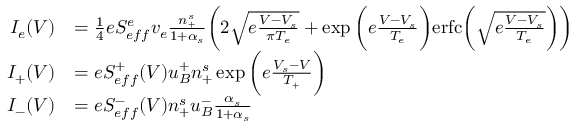<formula> <loc_0><loc_0><loc_500><loc_500>\begin{array} { r l } { I _ { e } ( V ) } & { = \frac { 1 } { 4 } e S _ { e f f } ^ { e } v _ { e } \frac { n _ { + } ^ { s } } { 1 + \alpha _ { s } } \left ( 2 \sqrt { e \frac { V - V _ { s } } { \pi T _ { e } } } + \exp { \left ( e \frac { V - V _ { s } } { T _ { e } } } \right ) e r f c \left ( { \sqrt { e \frac { V - V _ { s } } { T _ { e } } } } \right ) \right ) } \\ { I _ { + } ( V ) } & { = e S _ { e f f } ^ { + } ( V ) u _ { B } ^ { + } n _ { + } ^ { s } \exp \left ( { e \frac { V _ { s } - V } { T _ { + } } } \right ) } \\ { I _ { - } ( V ) } & { = e S _ { e f f } ^ { - } ( V ) n _ { + } ^ { s } u _ { B } ^ { - } \frac { \alpha _ { s } } { 1 + \alpha _ { s } } } \end{array}</formula> 